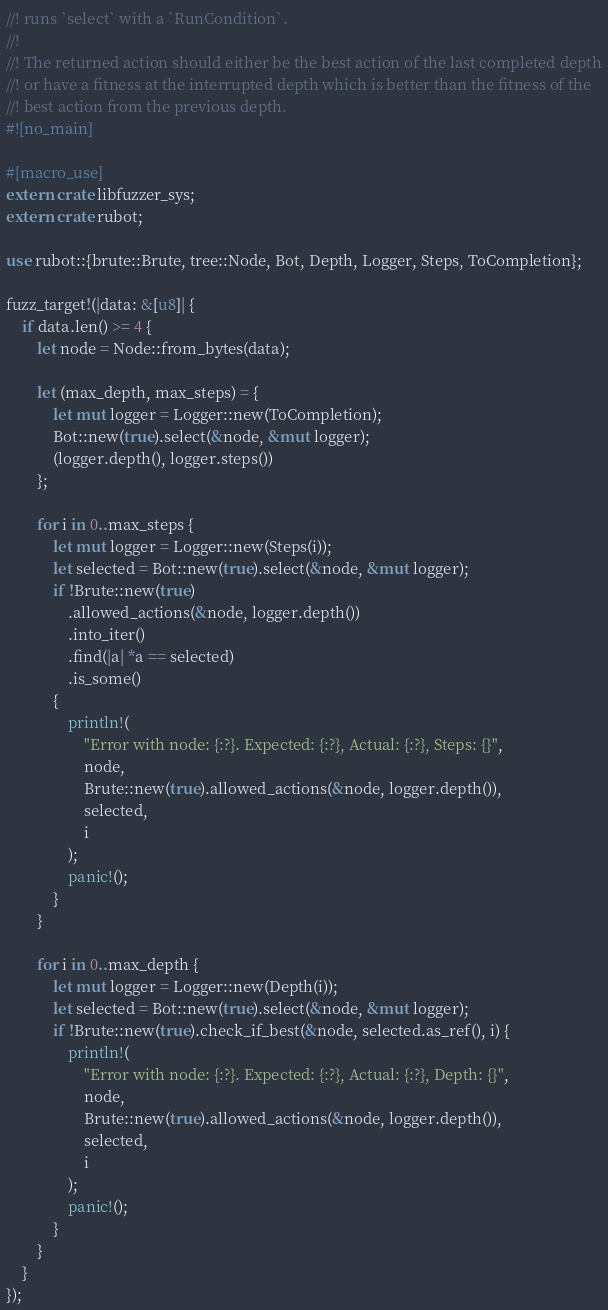Convert code to text. <code><loc_0><loc_0><loc_500><loc_500><_Rust_>//! runs `select` with a `RunCondition`.
//!
//! The returned action should either be the best action of the last completed depth
//! or have a fitness at the interrupted depth which is better than the fitness of the
//! best action from the previous depth.
#![no_main]

#[macro_use]
extern crate libfuzzer_sys;
extern crate rubot;

use rubot::{brute::Brute, tree::Node, Bot, Depth, Logger, Steps, ToCompletion};

fuzz_target!(|data: &[u8]| {
    if data.len() >= 4 {
        let node = Node::from_bytes(data);

        let (max_depth, max_steps) = {
            let mut logger = Logger::new(ToCompletion);
            Bot::new(true).select(&node, &mut logger);
            (logger.depth(), logger.steps())
        };

        for i in 0..max_steps {
            let mut logger = Logger::new(Steps(i));
            let selected = Bot::new(true).select(&node, &mut logger);
            if !Brute::new(true)
                .allowed_actions(&node, logger.depth())
                .into_iter()
                .find(|a| *a == selected)
                .is_some()
            {
                println!(
                    "Error with node: {:?}. Expected: {:?}, Actual: {:?}, Steps: {}",
                    node,
                    Brute::new(true).allowed_actions(&node, logger.depth()),
                    selected,
                    i
                );
                panic!();
            }
        }

        for i in 0..max_depth {
            let mut logger = Logger::new(Depth(i));
            let selected = Bot::new(true).select(&node, &mut logger);
            if !Brute::new(true).check_if_best(&node, selected.as_ref(), i) {
                println!(
                    "Error with node: {:?}. Expected: {:?}, Actual: {:?}, Depth: {}",
                    node,
                    Brute::new(true).allowed_actions(&node, logger.depth()),
                    selected,
                    i
                );
                panic!();
            }
        }
    }
});
</code> 